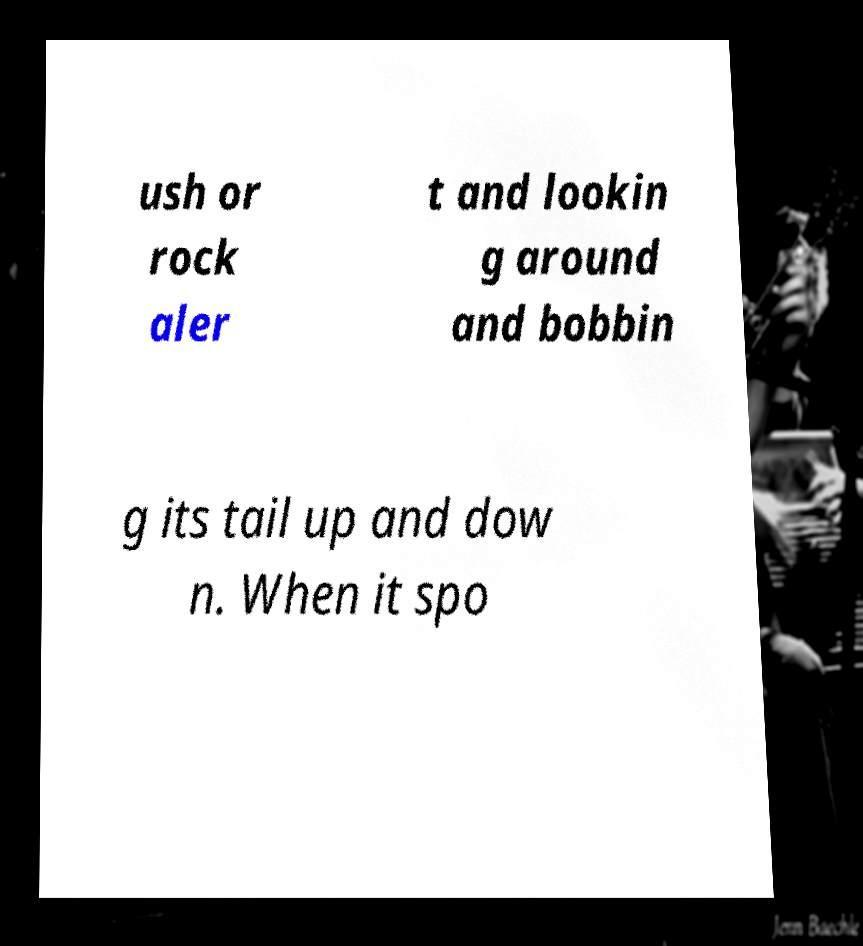Please identify and transcribe the text found in this image. ush or rock aler t and lookin g around and bobbin g its tail up and dow n. When it spo 